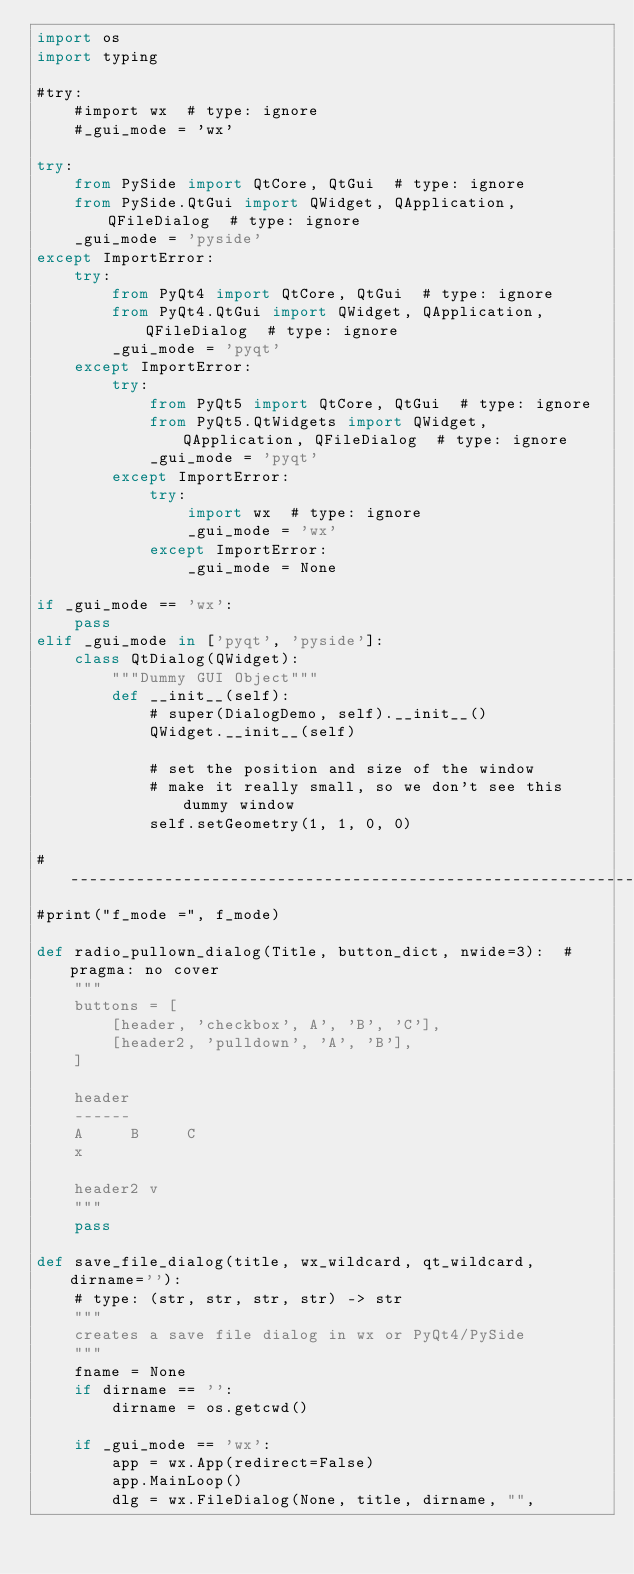Convert code to text. <code><loc_0><loc_0><loc_500><loc_500><_Python_>import os
import typing

#try:
    #import wx  # type: ignore
    #_gui_mode = 'wx'

try:
    from PySide import QtCore, QtGui  # type: ignore
    from PySide.QtGui import QWidget, QApplication, QFileDialog  # type: ignore
    _gui_mode = 'pyside'
except ImportError:
    try:
        from PyQt4 import QtCore, QtGui  # type: ignore
        from PyQt4.QtGui import QWidget, QApplication, QFileDialog  # type: ignore
        _gui_mode = 'pyqt'
    except ImportError:
        try:
            from PyQt5 import QtCore, QtGui  # type: ignore
            from PyQt5.QtWidgets import QWidget, QApplication, QFileDialog  # type: ignore
            _gui_mode = 'pyqt'
        except ImportError:
            try:
                import wx  # type: ignore
                _gui_mode = 'wx'
            except ImportError:
                _gui_mode = None

if _gui_mode == 'wx':
    pass
elif _gui_mode in ['pyqt', 'pyside']:
    class QtDialog(QWidget):
        """Dummy GUI Object"""
        def __init__(self):
            # super(DialogDemo, self).__init__()
            QWidget.__init__(self)

            # set the position and size of the window
            # make it really small, so we don't see this dummy window
            self.setGeometry(1, 1, 0, 0)

#----------------------------------------------------------------------
#print("f_mode =", f_mode)

def radio_pullown_dialog(Title, button_dict, nwide=3):  # pragma: no cover
    """
    buttons = [
        [header, 'checkbox', A', 'B', 'C'],
        [header2, 'pulldown', 'A', 'B'],
    ]

    header
    ------
    A     B     C
    x

    header2 v
    """
    pass

def save_file_dialog(title, wx_wildcard, qt_wildcard, dirname=''):
    # type: (str, str, str, str) -> str
    """
    creates a save file dialog in wx or PyQt4/PySide
    """
    fname = None
    if dirname == '':
        dirname = os.getcwd()

    if _gui_mode == 'wx':
        app = wx.App(redirect=False)
        app.MainLoop()
        dlg = wx.FileDialog(None, title, dirname, "",</code> 